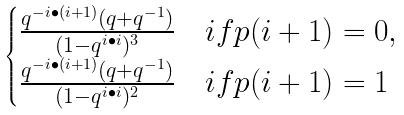Convert formula to latex. <formula><loc_0><loc_0><loc_500><loc_500>\begin{cases} \frac { q ^ { - i \bullet ( i + 1 ) } ( q + q ^ { - 1 } ) } { ( 1 - q ^ { i \bullet i } ) ^ { 3 } } & i f p ( i + 1 ) = 0 , \\ \frac { q ^ { - i \bullet ( i + 1 ) } ( q + q ^ { - 1 } ) } { ( 1 - q ^ { i \bullet i } ) ^ { 2 } } & i f p ( i + 1 ) = 1 \end{cases}</formula> 